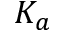<formula> <loc_0><loc_0><loc_500><loc_500>K _ { a }</formula> 